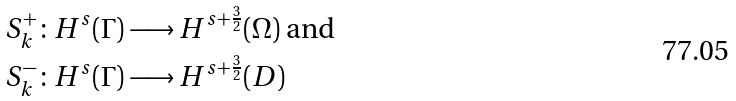Convert formula to latex. <formula><loc_0><loc_0><loc_500><loc_500>& S _ { k } ^ { + } \colon H ^ { s } ( \Gamma ) \longrightarrow H ^ { s + \frac { 3 } { 2 } } ( \Omega ) \text { and } \\ & S _ { k } ^ { - } \colon H ^ { s } ( \Gamma ) \longrightarrow H ^ { s + \frac { 3 } { 2 } } ( D )</formula> 